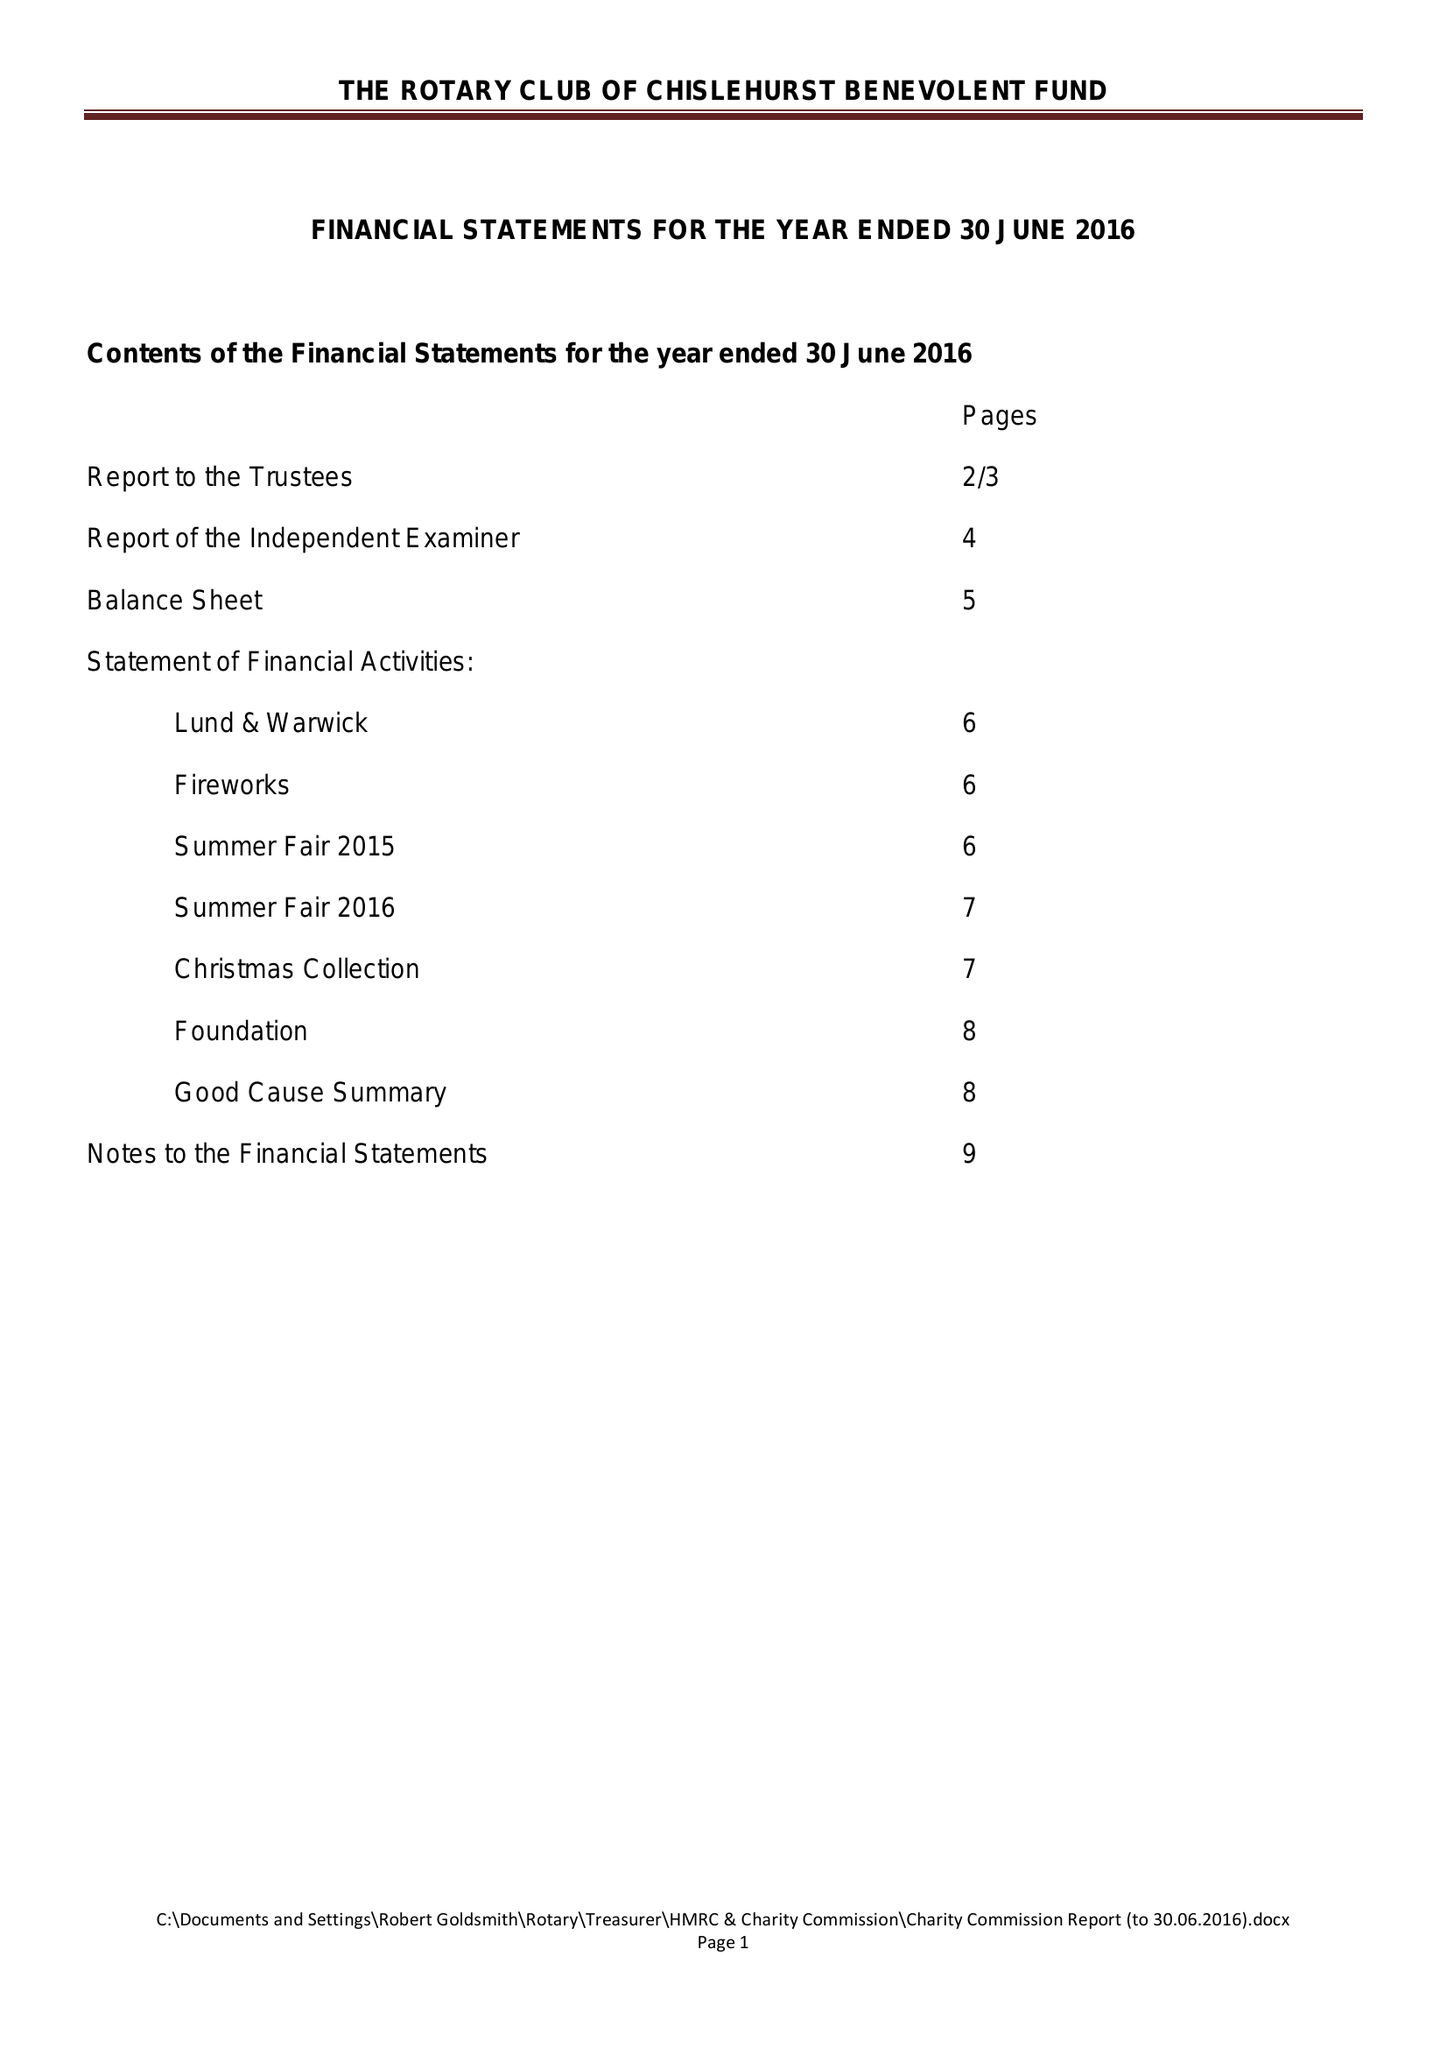What is the value for the address__postcode?
Answer the question using a single word or phrase. BR6 7RS 